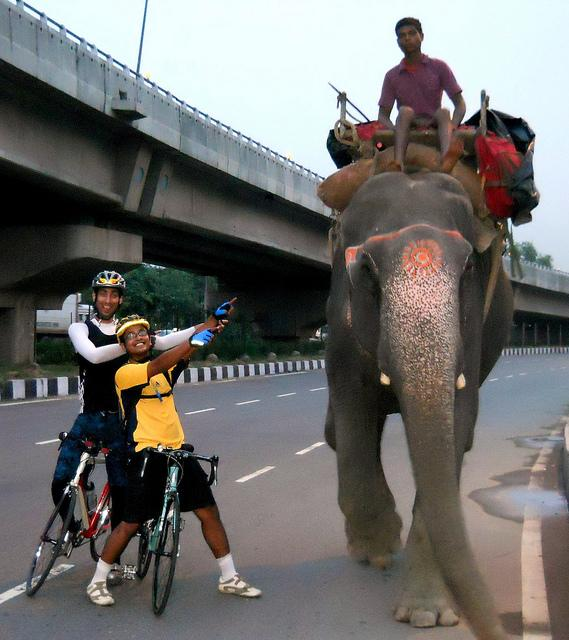What are the helmets shells made from? plastic 